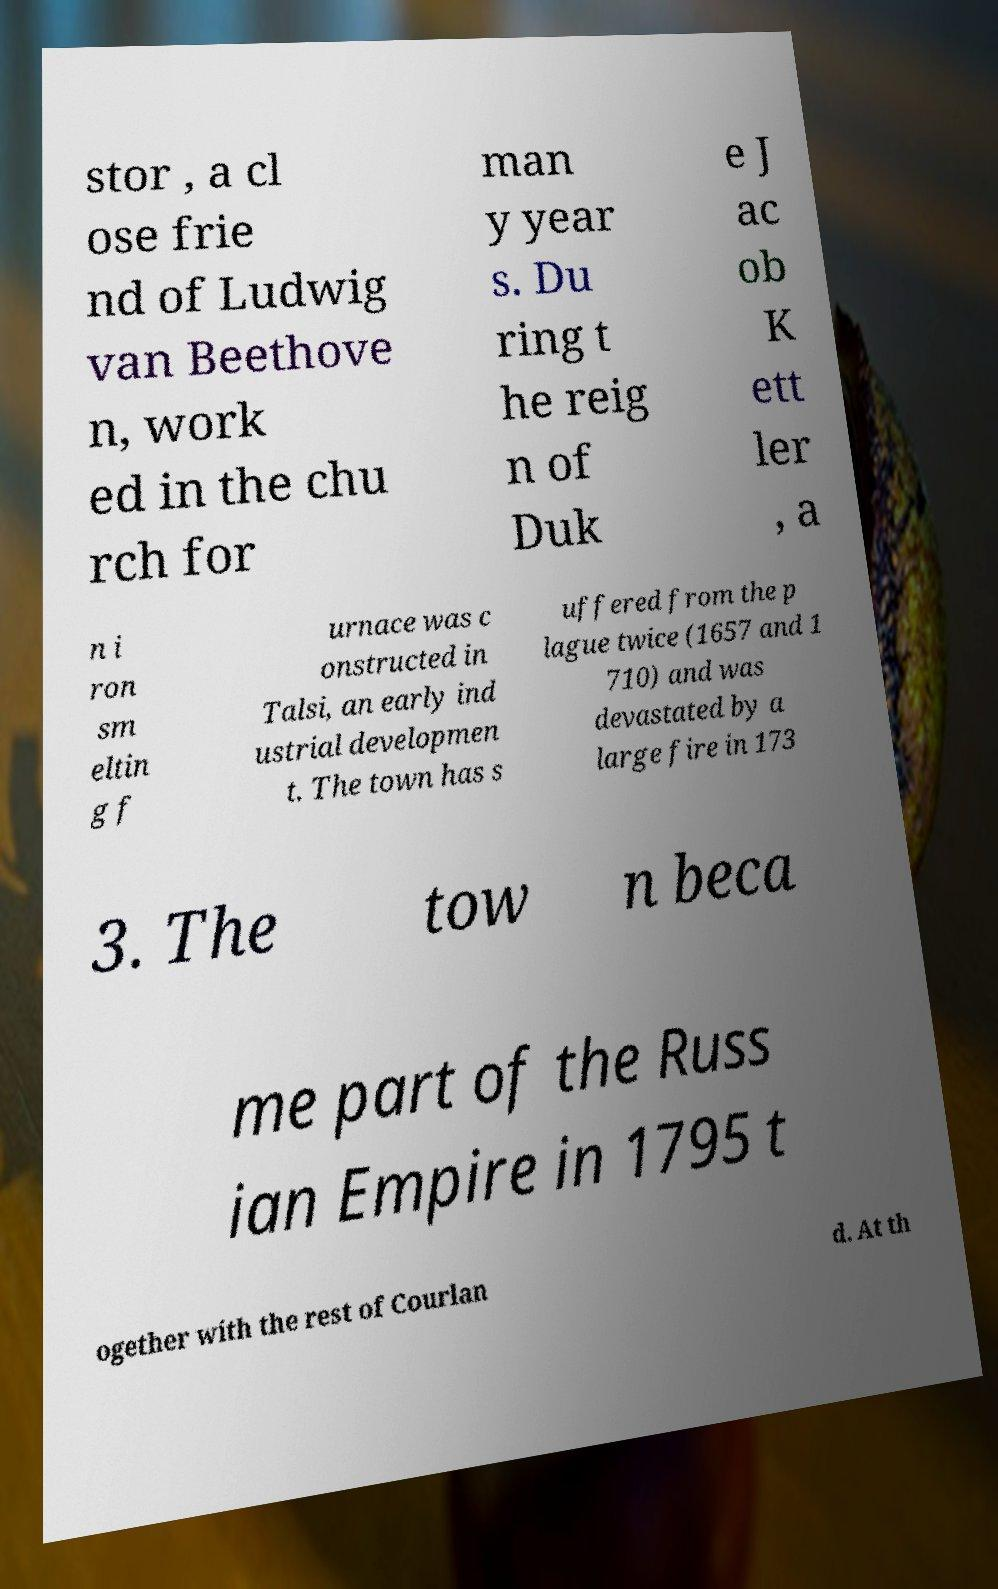Please read and relay the text visible in this image. What does it say? stor , a cl ose frie nd of Ludwig van Beethove n, work ed in the chu rch for man y year s. Du ring t he reig n of Duk e J ac ob K ett ler , a n i ron sm eltin g f urnace was c onstructed in Talsi, an early ind ustrial developmen t. The town has s uffered from the p lague twice (1657 and 1 710) and was devastated by a large fire in 173 3. The tow n beca me part of the Russ ian Empire in 1795 t ogether with the rest of Courlan d. At th 